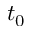<formula> <loc_0><loc_0><loc_500><loc_500>t _ { 0 }</formula> 